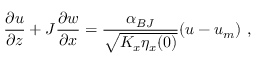<formula> <loc_0><loc_0><loc_500><loc_500>\frac { \partial u } { \partial z } + J \frac { \partial w } { \partial x } = \frac { \alpha _ { B J } } { \sqrt { K _ { x } \eta _ { x } ( 0 ) } } ( u - u _ { m } ) ,</formula> 